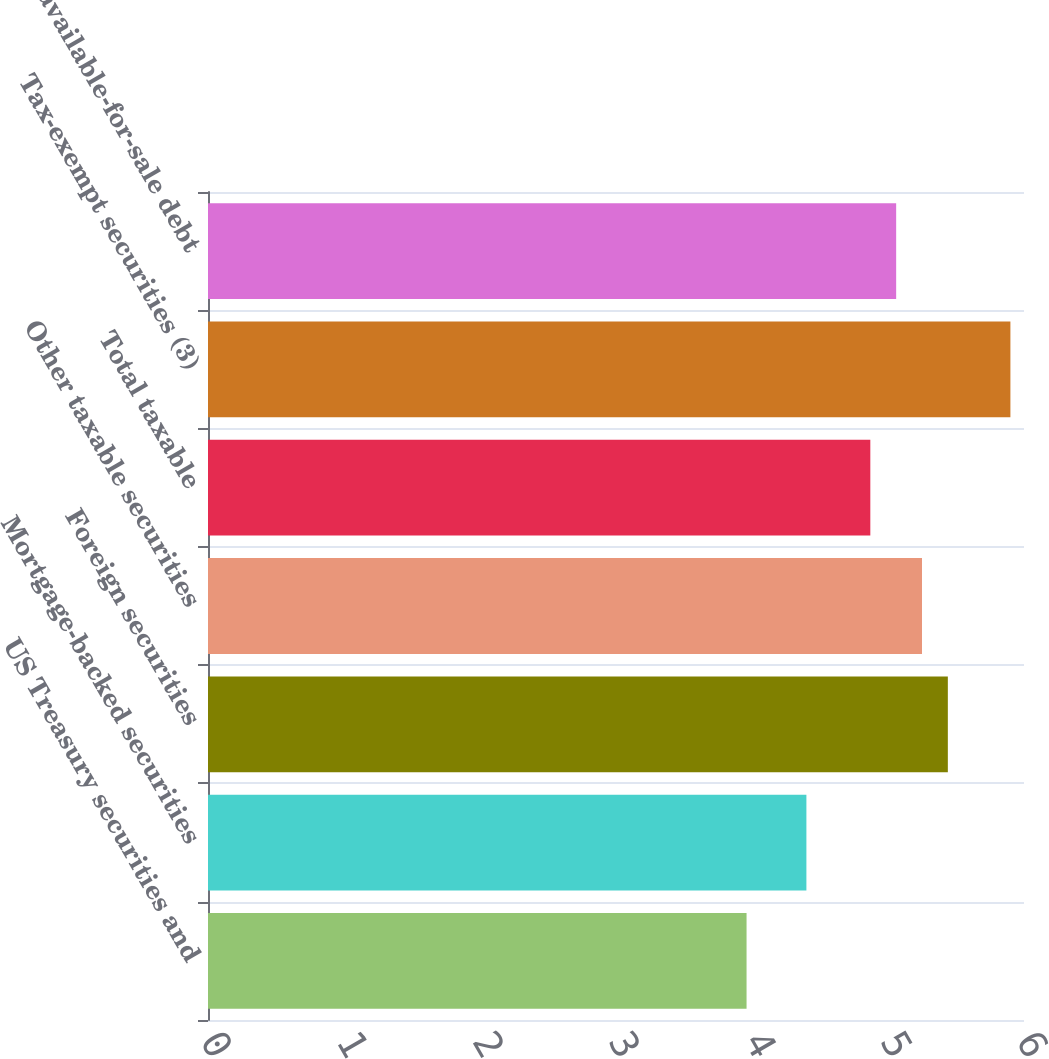Convert chart. <chart><loc_0><loc_0><loc_500><loc_500><bar_chart><fcel>US Treasury securities and<fcel>Mortgage-backed securities<fcel>Foreign securities<fcel>Other taxable securities<fcel>Total taxable<fcel>Tax-exempt securities (3)<fcel>Total available-for-sale debt<nl><fcel>3.96<fcel>4.4<fcel>5.44<fcel>5.25<fcel>4.87<fcel>5.9<fcel>5.06<nl></chart> 